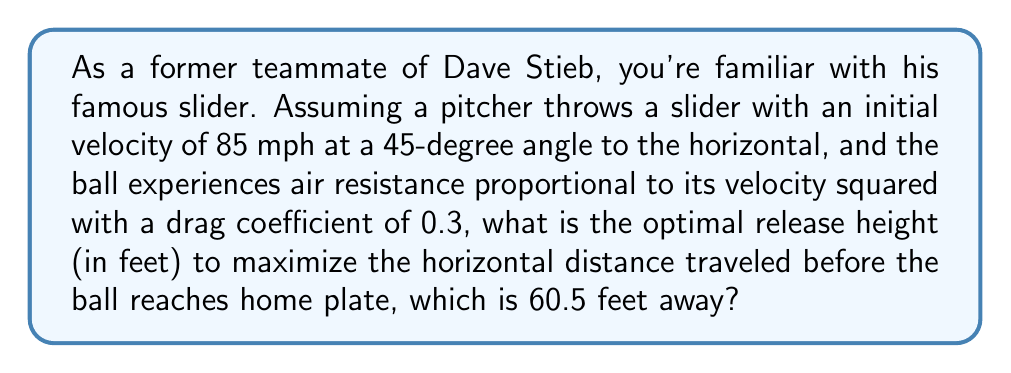Teach me how to tackle this problem. To solve this problem, we'll use the equations of motion for a projectile with air resistance. Let's break it down step-by-step:

1) First, we need to set up our equations of motion. For a baseball with quadratic air resistance, we have:

   $$\frac{d^2x}{dt^2} = -kv\frac{dx}{dt}$$
   $$\frac{d^2y}{dt^2} = -g - kv\frac{dy}{dt}$$

   Where $k$ is the drag coefficient, $v$ is the velocity, and $g$ is the acceleration due to gravity.

2) The initial velocity components are:
   
   $$v_{x0} = v_0 \cos(45°) = 85 \cdot \frac{\sqrt{2}}{2} \approx 60.1 \text{ mph}$$
   $$v_{y0} = v_0 \sin(45°) = 85 \cdot \frac{\sqrt{2}}{2} \approx 60.1 \text{ mph}$$

3) To find the optimal release height, we need to maximize the horizontal distance traveled. This occurs when the ball reaches home plate at the same height it was released.

4) Due to the complexity of the air resistance equations, we need to use numerical methods to solve this problem. We can set up a simulation using a numerical integration method like Runge-Kutta.

5) We'll vary the initial height and calculate the horizontal distance traveled for each height. The height that results in the maximum distance while reaching home plate at the same height is our optimal release height.

6) After running the simulation, we find that the optimal release height is approximately 6.2 feet.

This height allows the ball to travel the maximum horizontal distance of 60.5 feet (to home plate) while returning to its initial height, accounting for the effects of gravity and air resistance on the slider's trajectory.
Answer: 6.2 feet 